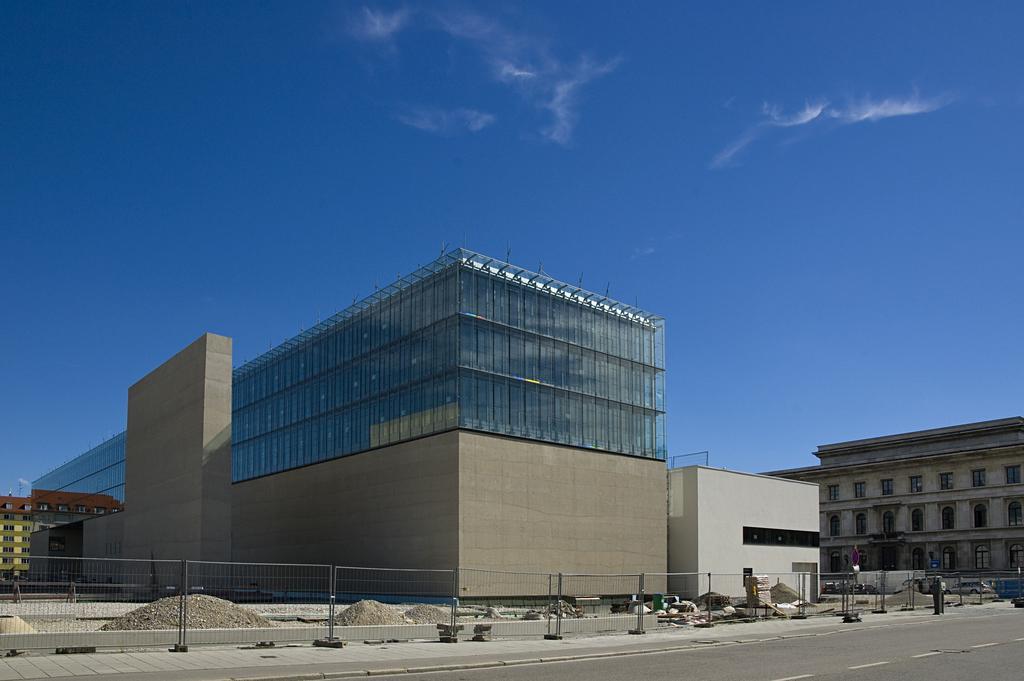Can you describe this image briefly? In this image we can see road, fencing there are some buildings and top of the image there is clear sky. 